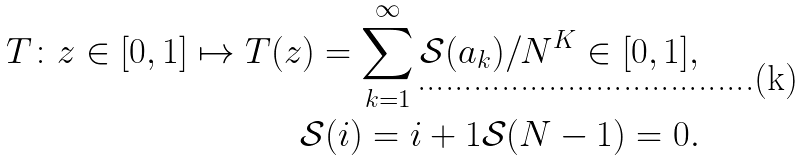<formula> <loc_0><loc_0><loc_500><loc_500>T \colon z \in [ 0 , 1 ] \mapsto T ( z ) = \sum ^ { \infty } _ { k = 1 } \mathcal { S } ( a _ { k } ) / N ^ { K } \in [ 0 , 1 ] , \\ \mathcal { S } ( i ) = i + 1 \mathcal { S } ( N - 1 ) = 0 .</formula> 